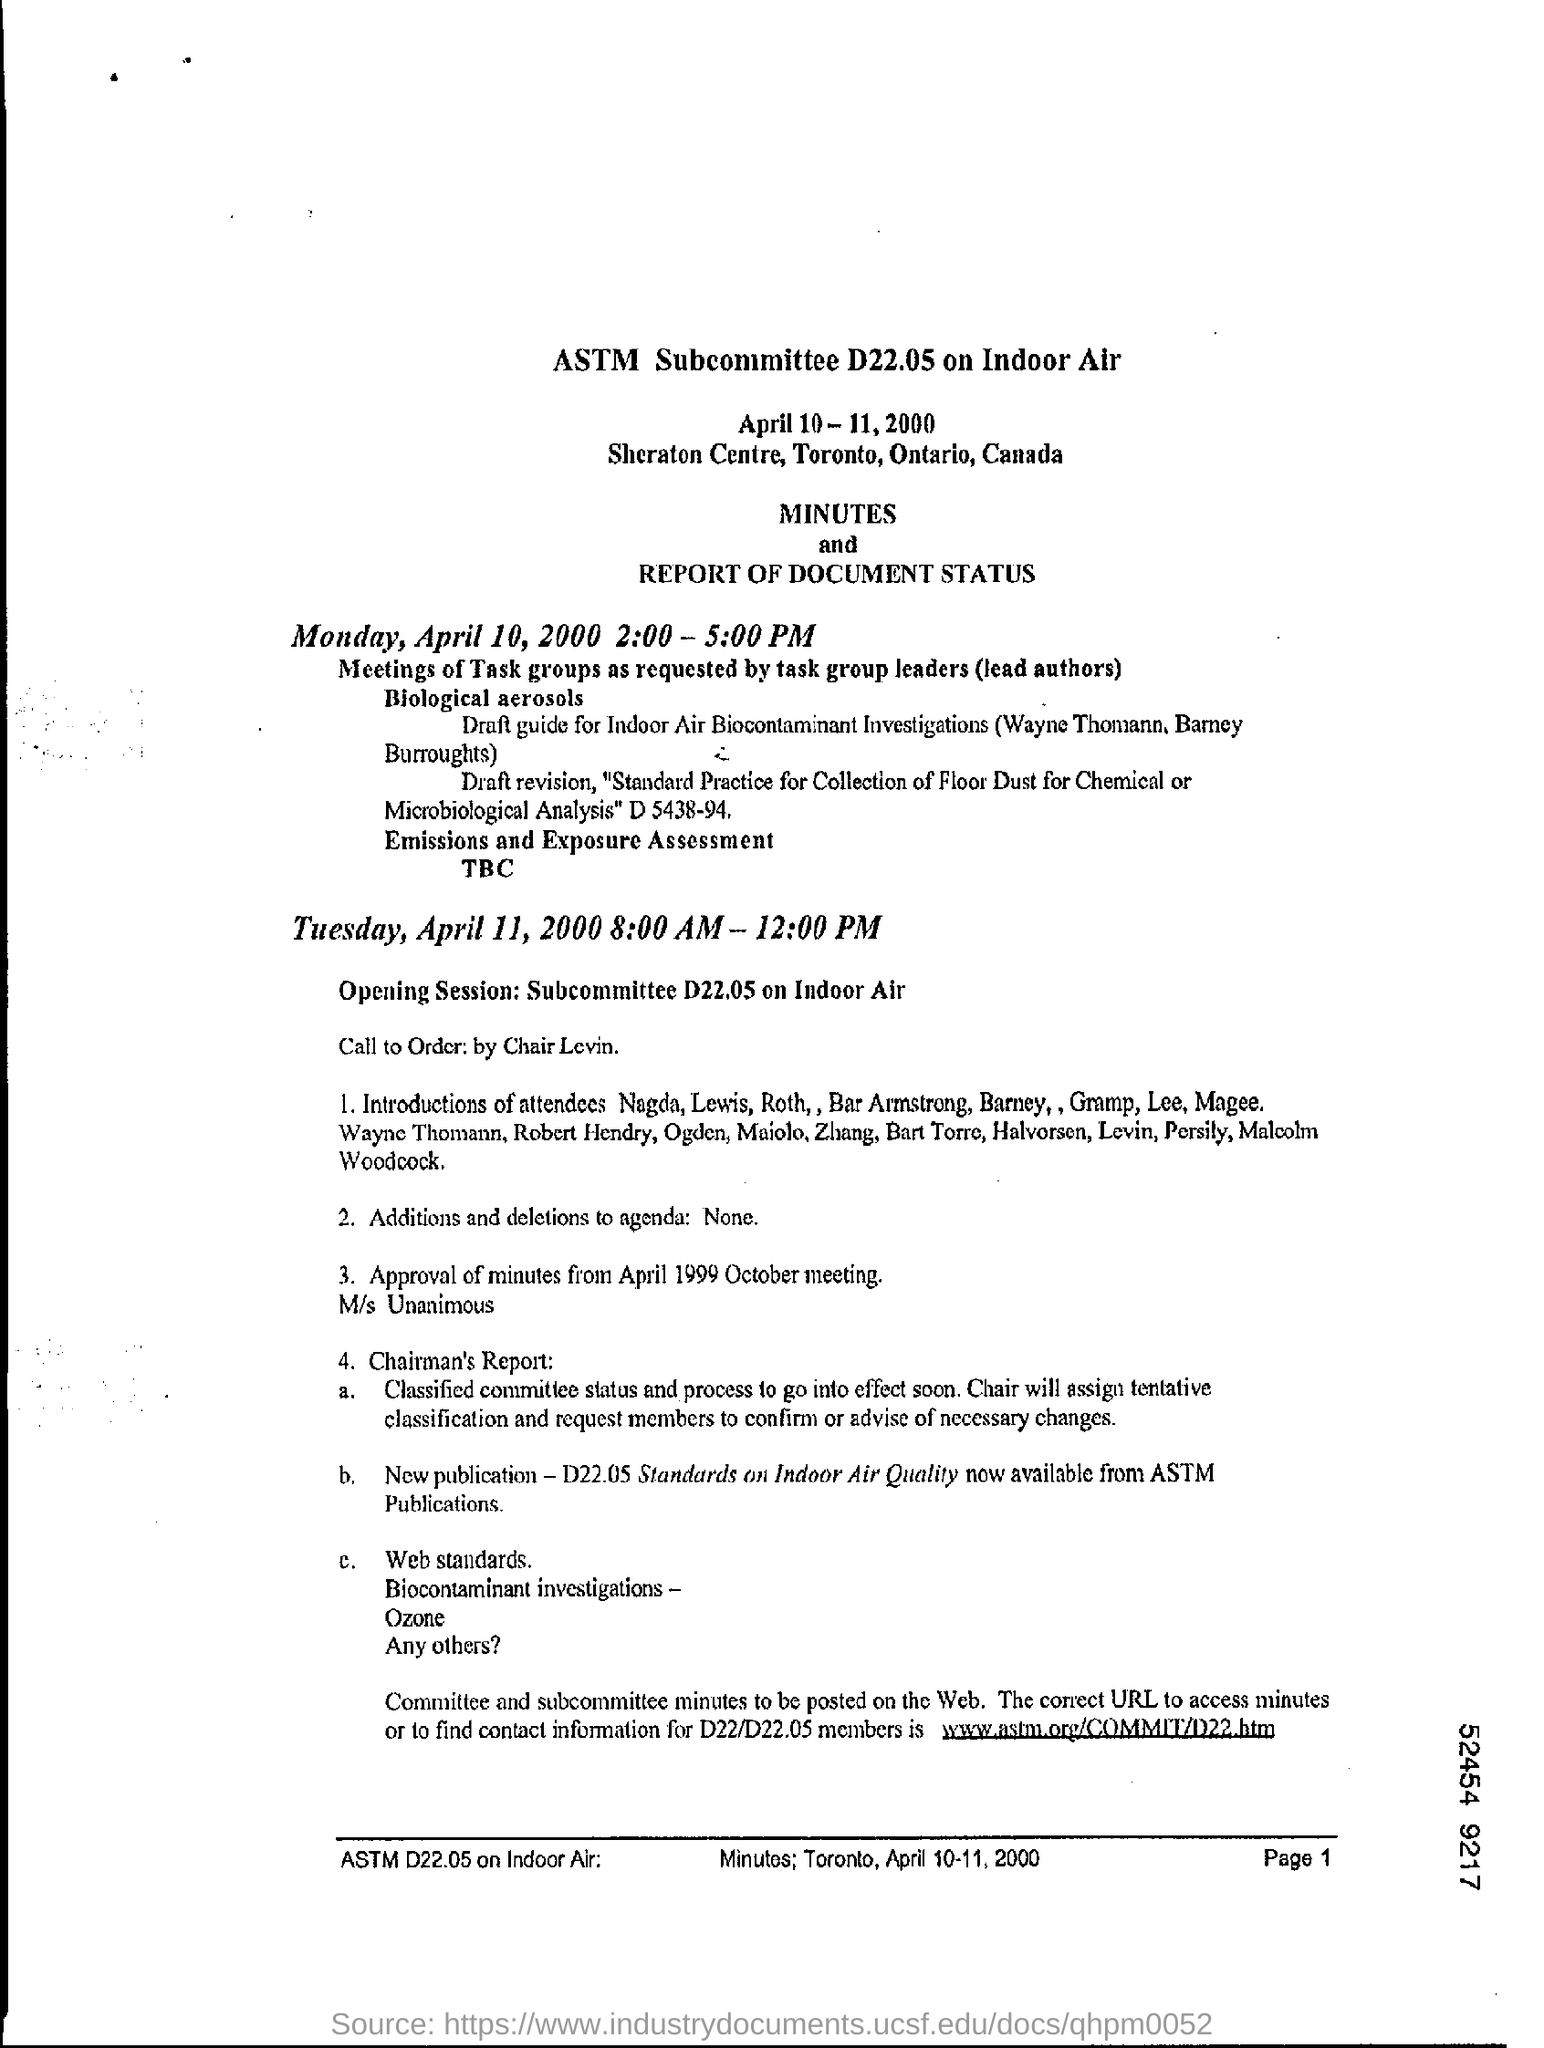Specify some key components in this picture. It is necessary to mention the page number at the bottom right corner of each page in a document. April 10, 2000 was a Monday. 